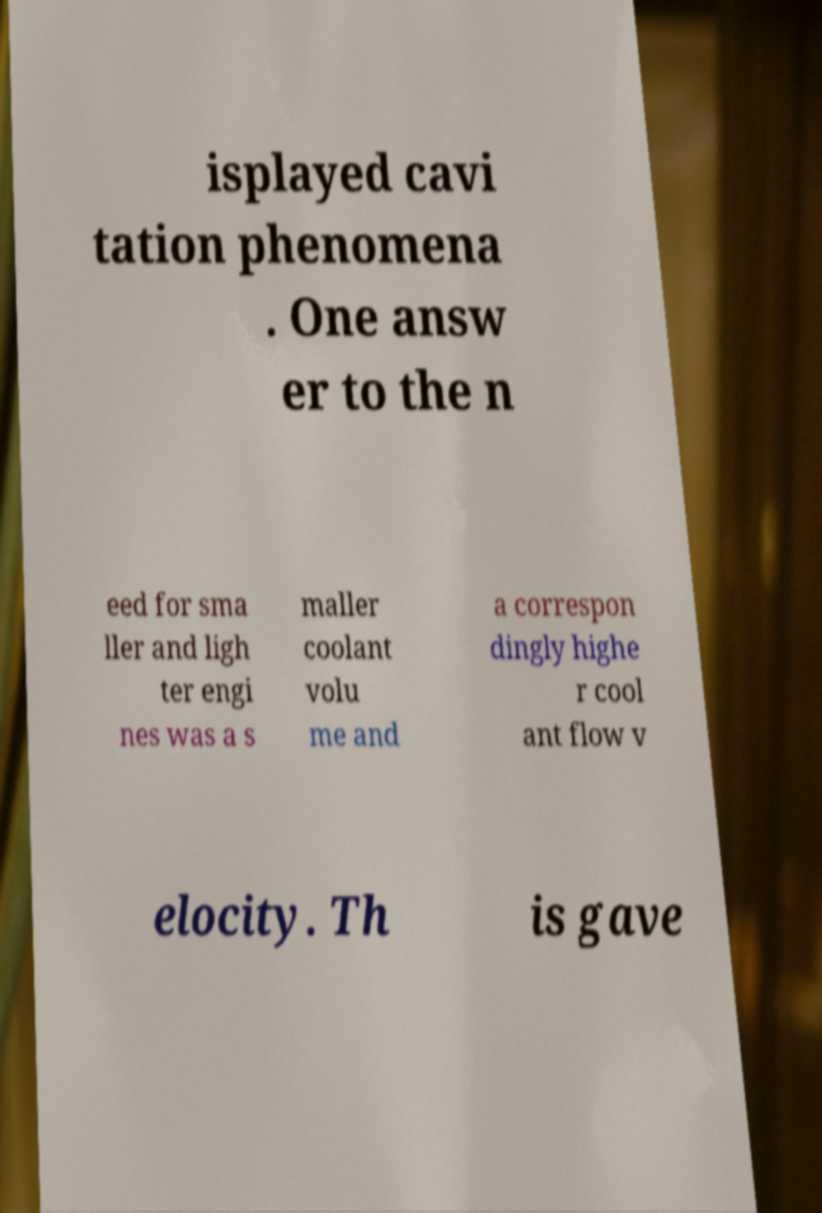Could you assist in decoding the text presented in this image and type it out clearly? isplayed cavi tation phenomena . One answ er to the n eed for sma ller and ligh ter engi nes was a s maller coolant volu me and a correspon dingly highe r cool ant flow v elocity. Th is gave 